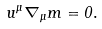Convert formula to latex. <formula><loc_0><loc_0><loc_500><loc_500>u ^ { \mu } \nabla _ { \mu } m = 0 .</formula> 